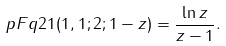Convert formula to latex. <formula><loc_0><loc_0><loc_500><loc_500>\ p F q 2 1 ( 1 , 1 ; 2 ; 1 - z ) = \frac { \ln z } { z - 1 } .</formula> 